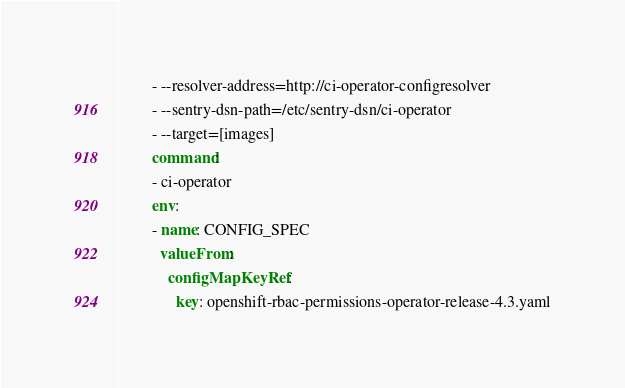Convert code to text. <code><loc_0><loc_0><loc_500><loc_500><_YAML_>        - --resolver-address=http://ci-operator-configresolver
        - --sentry-dsn-path=/etc/sentry-dsn/ci-operator
        - --target=[images]
        command:
        - ci-operator
        env:
        - name: CONFIG_SPEC
          valueFrom:
            configMapKeyRef:
              key: openshift-rbac-permissions-operator-release-4.3.yaml</code> 